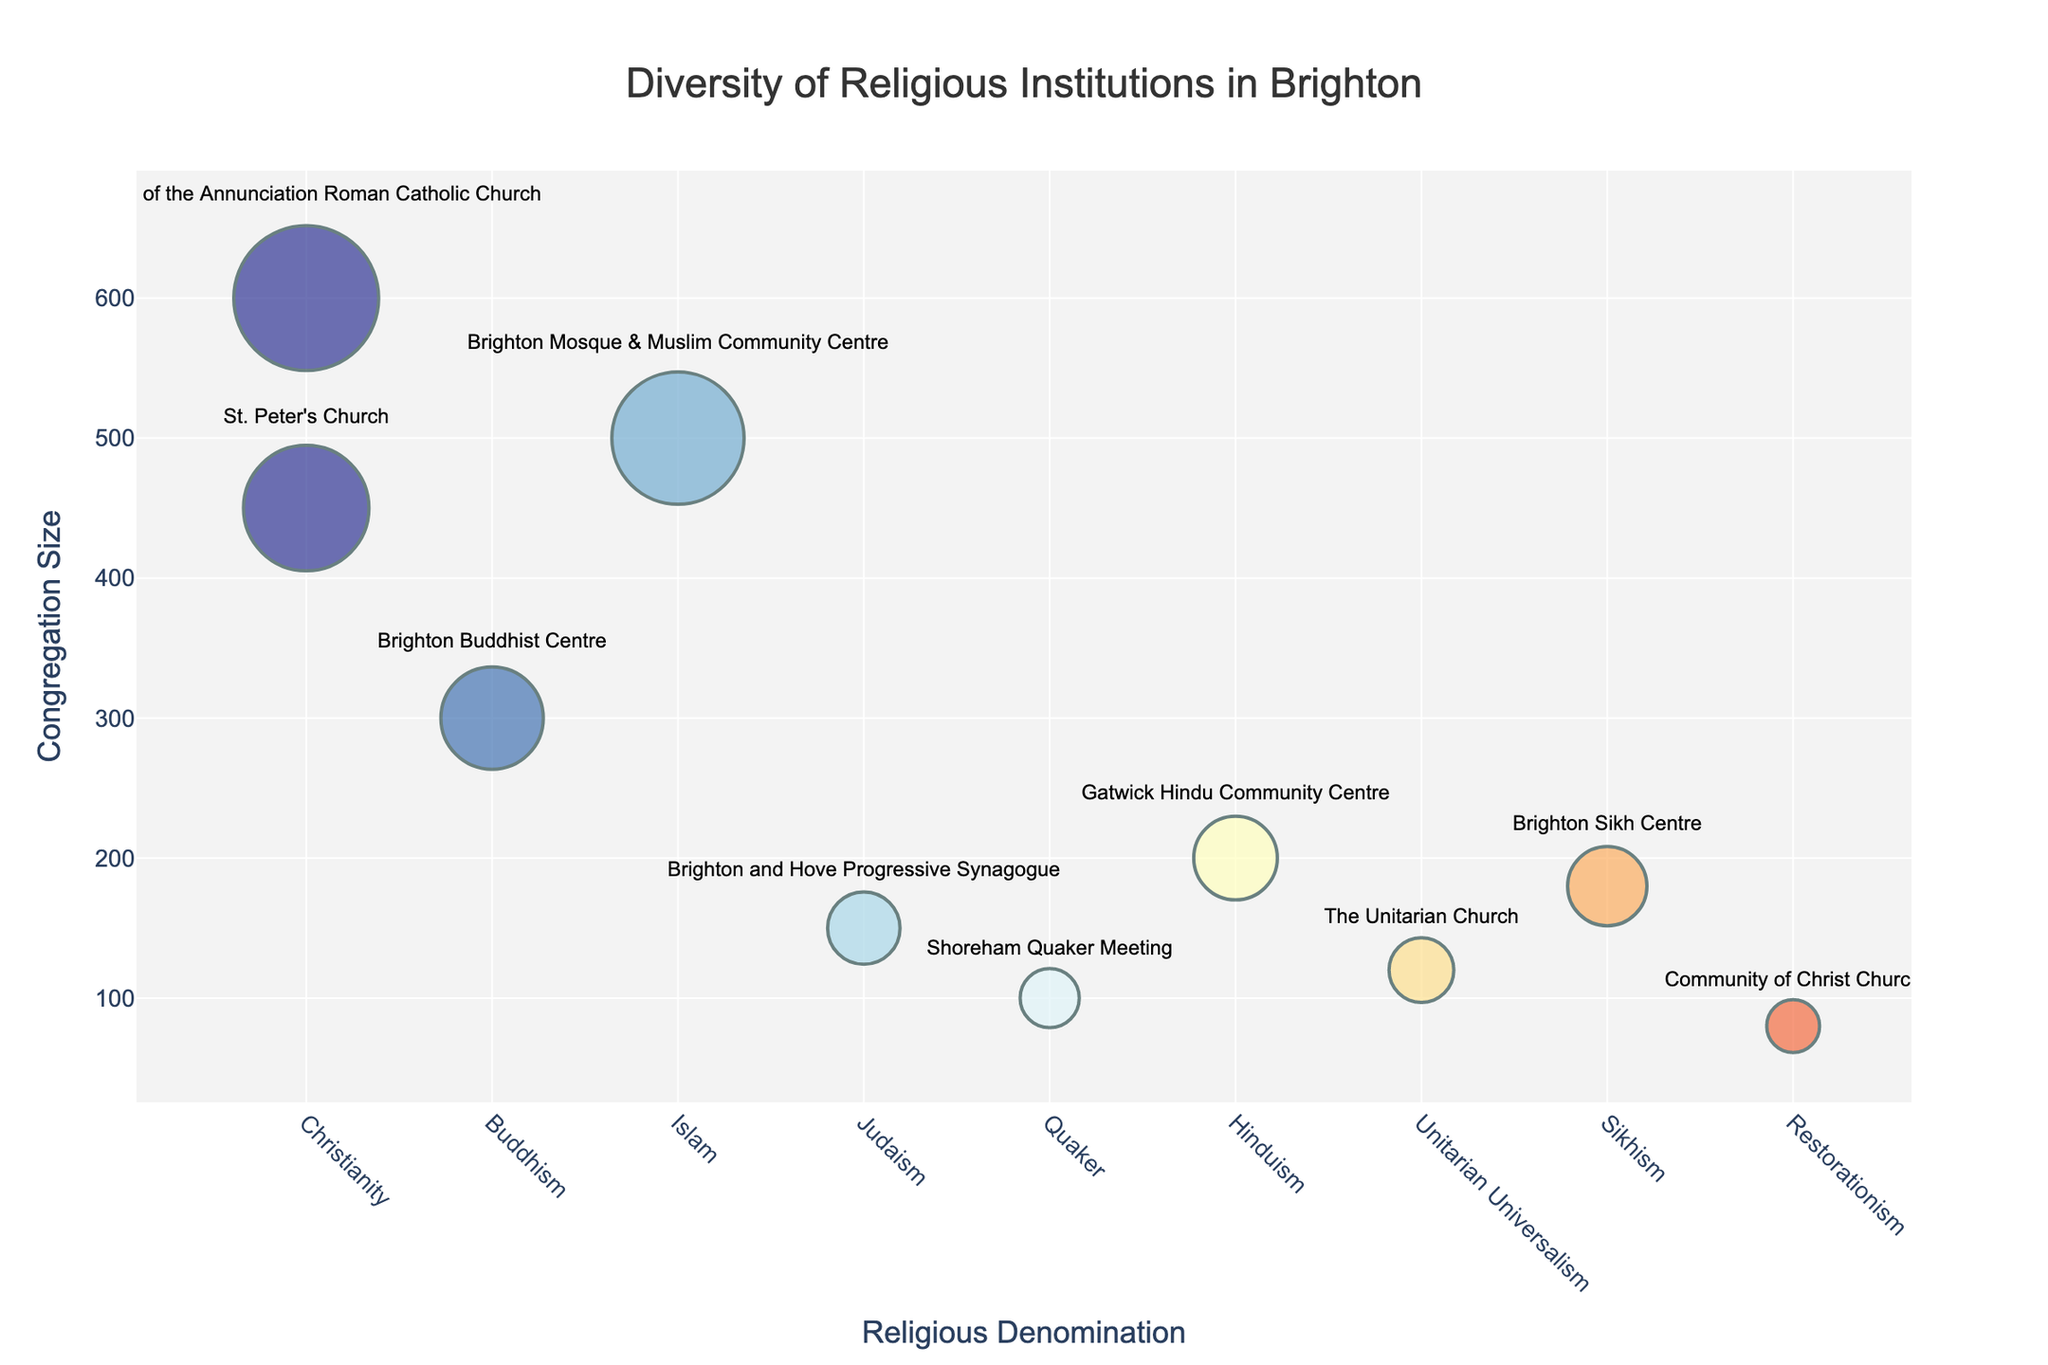Which religious institution has the largest congregation size? By looking at the 'Congregation Size' values on the y-axis and the bubble sizes, identify the institution with the largest bubble. 'Church of the Annunciation Roman Catholic Church' has the largest bubble representing the largest size of 600.
Answer: Church of the Annunciation Roman Catholic Church How many religious institutions are shown in the bubble chart? Count the total number of distinct bubbles on the chart. There are 10 distinct bubbles each representing a different religious institution.
Answer: 10 Which two denominations share the Christian religion, and what are their congregation sizes? Identify the two institutions labeled under 'Christianity' and check their 'Congregation Size' on the y-axis. 'St. Peter's Church' has a congregation size of 450 and 'Church of the Annunciation Roman Catholic Church' has a size of 600.
Answer: St. Peter's Church (450) and Church of the Annunciation Roman Catholic Church (600) What’s the median congregation size of all institutions? First, list all the sizes (450, 300, 500, 150, 100, 200, 120, 180, 600, 80). Then, order them (80, 100, 120, 150, 180, 200, 300, 450, 500, 600). Since there are 10 values, the median is the average of the 5th and 6th values, (180+200)/2 = 190.
Answer: 190 What’s the average congregation size? Sum the congregation sizes (450 + 300 + 500 + 150 + 100 + 200 + 120 + 180 + 600 + 80 = 2680) and divide by the number of institutions (10). The average is 2680/10 = 268.
Answer: 268 Which denomination has the smallest congregation size? Identify the smallest bubble on the y-axis, which corresponds to 'Community of Christ Church' under 'Restorationism' with a size of 80.
Answer: Restorationism (Community of Christ Church) What’s the total number of people represented by all the religious institutions combined? Sum the congregation sizes: 450 + 300 + 500 + 150 + 100 + 200 + 120 + 180 + 600 + 80. The sum is 2680.
Answer: 2680 Which institution represents Sikhism, and what’s its congregation size? Locate the bubble labeled 'Sikhism' and check the y-axis value. 'Brighton Sikh Centre' is the institution with a congregation size of 180.
Answer: Brighton Sikh Centre (180) Compare the congregation sizes of 'Gatwick Hindu Community Centre' and 'The Unitarian Church’. Which one is larger and by how much? Check the y-axis values for both; 'Gatwick Hindu Community Centre' is 200 and 'The Unitarian Church' is 120. The difference is 200 - 120 = 80.
Answer: Gatwick Hindu Community Centre by 80 